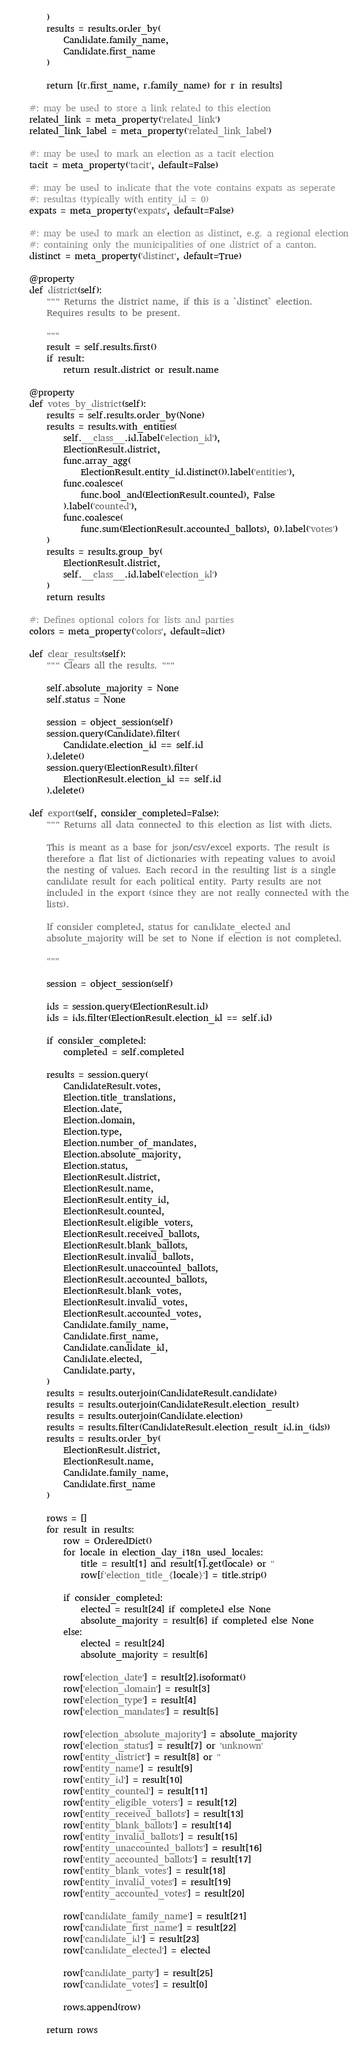<code> <loc_0><loc_0><loc_500><loc_500><_Python_>        )
        results = results.order_by(
            Candidate.family_name,
            Candidate.first_name
        )

        return [(r.first_name, r.family_name) for r in results]

    #: may be used to store a link related to this election
    related_link = meta_property('related_link')
    related_link_label = meta_property('related_link_label')

    #: may be used to mark an election as a tacit election
    tacit = meta_property('tacit', default=False)

    #: may be used to indicate that the vote contains expats as seperate
    #: resultas (typically with entity_id = 0)
    expats = meta_property('expats', default=False)

    #: may be used to mark an election as distinct, e.g. a regional election
    #: containing only the municipalities of one district of a canton.
    distinct = meta_property('distinct', default=True)

    @property
    def district(self):
        """ Returns the district name, if this is a `distinct` election.
        Requires results to be present.

        """
        result = self.results.first()
        if result:
            return result.district or result.name

    @property
    def votes_by_district(self):
        results = self.results.order_by(None)
        results = results.with_entities(
            self.__class__.id.label('election_id'),
            ElectionResult.district,
            func.array_agg(
                ElectionResult.entity_id.distinct()).label('entities'),
            func.coalesce(
                func.bool_and(ElectionResult.counted), False
            ).label('counted'),
            func.coalesce(
                func.sum(ElectionResult.accounted_ballots), 0).label('votes')
        )
        results = results.group_by(
            ElectionResult.district,
            self.__class__.id.label('election_id')
        )
        return results

    #: Defines optional colors for lists and parties
    colors = meta_property('colors', default=dict)

    def clear_results(self):
        """ Clears all the results. """

        self.absolute_majority = None
        self.status = None

        session = object_session(self)
        session.query(Candidate).filter(
            Candidate.election_id == self.id
        ).delete()
        session.query(ElectionResult).filter(
            ElectionResult.election_id == self.id
        ).delete()

    def export(self, consider_completed=False):
        """ Returns all data connected to this election as list with dicts.

        This is meant as a base for json/csv/excel exports. The result is
        therefore a flat list of dictionaries with repeating values to avoid
        the nesting of values. Each record in the resulting list is a single
        candidate result for each political entity. Party results are not
        included in the export (since they are not really connected with the
        lists).

        If consider completed, status for candidate_elected and
        absolute_majority will be set to None if election is not completed.

        """

        session = object_session(self)

        ids = session.query(ElectionResult.id)
        ids = ids.filter(ElectionResult.election_id == self.id)

        if consider_completed:
            completed = self.completed

        results = session.query(
            CandidateResult.votes,
            Election.title_translations,
            Election.date,
            Election.domain,
            Election.type,
            Election.number_of_mandates,
            Election.absolute_majority,
            Election.status,
            ElectionResult.district,
            ElectionResult.name,
            ElectionResult.entity_id,
            ElectionResult.counted,
            ElectionResult.eligible_voters,
            ElectionResult.received_ballots,
            ElectionResult.blank_ballots,
            ElectionResult.invalid_ballots,
            ElectionResult.unaccounted_ballots,
            ElectionResult.accounted_ballots,
            ElectionResult.blank_votes,
            ElectionResult.invalid_votes,
            ElectionResult.accounted_votes,
            Candidate.family_name,
            Candidate.first_name,
            Candidate.candidate_id,
            Candidate.elected,
            Candidate.party,
        )
        results = results.outerjoin(CandidateResult.candidate)
        results = results.outerjoin(CandidateResult.election_result)
        results = results.outerjoin(Candidate.election)
        results = results.filter(CandidateResult.election_result_id.in_(ids))
        results = results.order_by(
            ElectionResult.district,
            ElectionResult.name,
            Candidate.family_name,
            Candidate.first_name
        )

        rows = []
        for result in results:
            row = OrderedDict()
            for locale in election_day_i18n_used_locales:
                title = result[1] and result[1].get(locale) or ''
                row[f'election_title_{locale}'] = title.strip()

            if consider_completed:
                elected = result[24] if completed else None
                absolute_majority = result[6] if completed else None
            else:
                elected = result[24]
                absolute_majority = result[6]

            row['election_date'] = result[2].isoformat()
            row['election_domain'] = result[3]
            row['election_type'] = result[4]
            row['election_mandates'] = result[5]

            row['election_absolute_majority'] = absolute_majority
            row['election_status'] = result[7] or 'unknown'
            row['entity_district'] = result[8] or ''
            row['entity_name'] = result[9]
            row['entity_id'] = result[10]
            row['entity_counted'] = result[11]
            row['entity_eligible_voters'] = result[12]
            row['entity_received_ballots'] = result[13]
            row['entity_blank_ballots'] = result[14]
            row['entity_invalid_ballots'] = result[15]
            row['entity_unaccounted_ballots'] = result[16]
            row['entity_accounted_ballots'] = result[17]
            row['entity_blank_votes'] = result[18]
            row['entity_invalid_votes'] = result[19]
            row['entity_accounted_votes'] = result[20]

            row['candidate_family_name'] = result[21]
            row['candidate_first_name'] = result[22]
            row['candidate_id'] = result[23]
            row['candidate_elected'] = elected

            row['candidate_party'] = result[25]
            row['candidate_votes'] = result[0]

            rows.append(row)

        return rows
</code> 